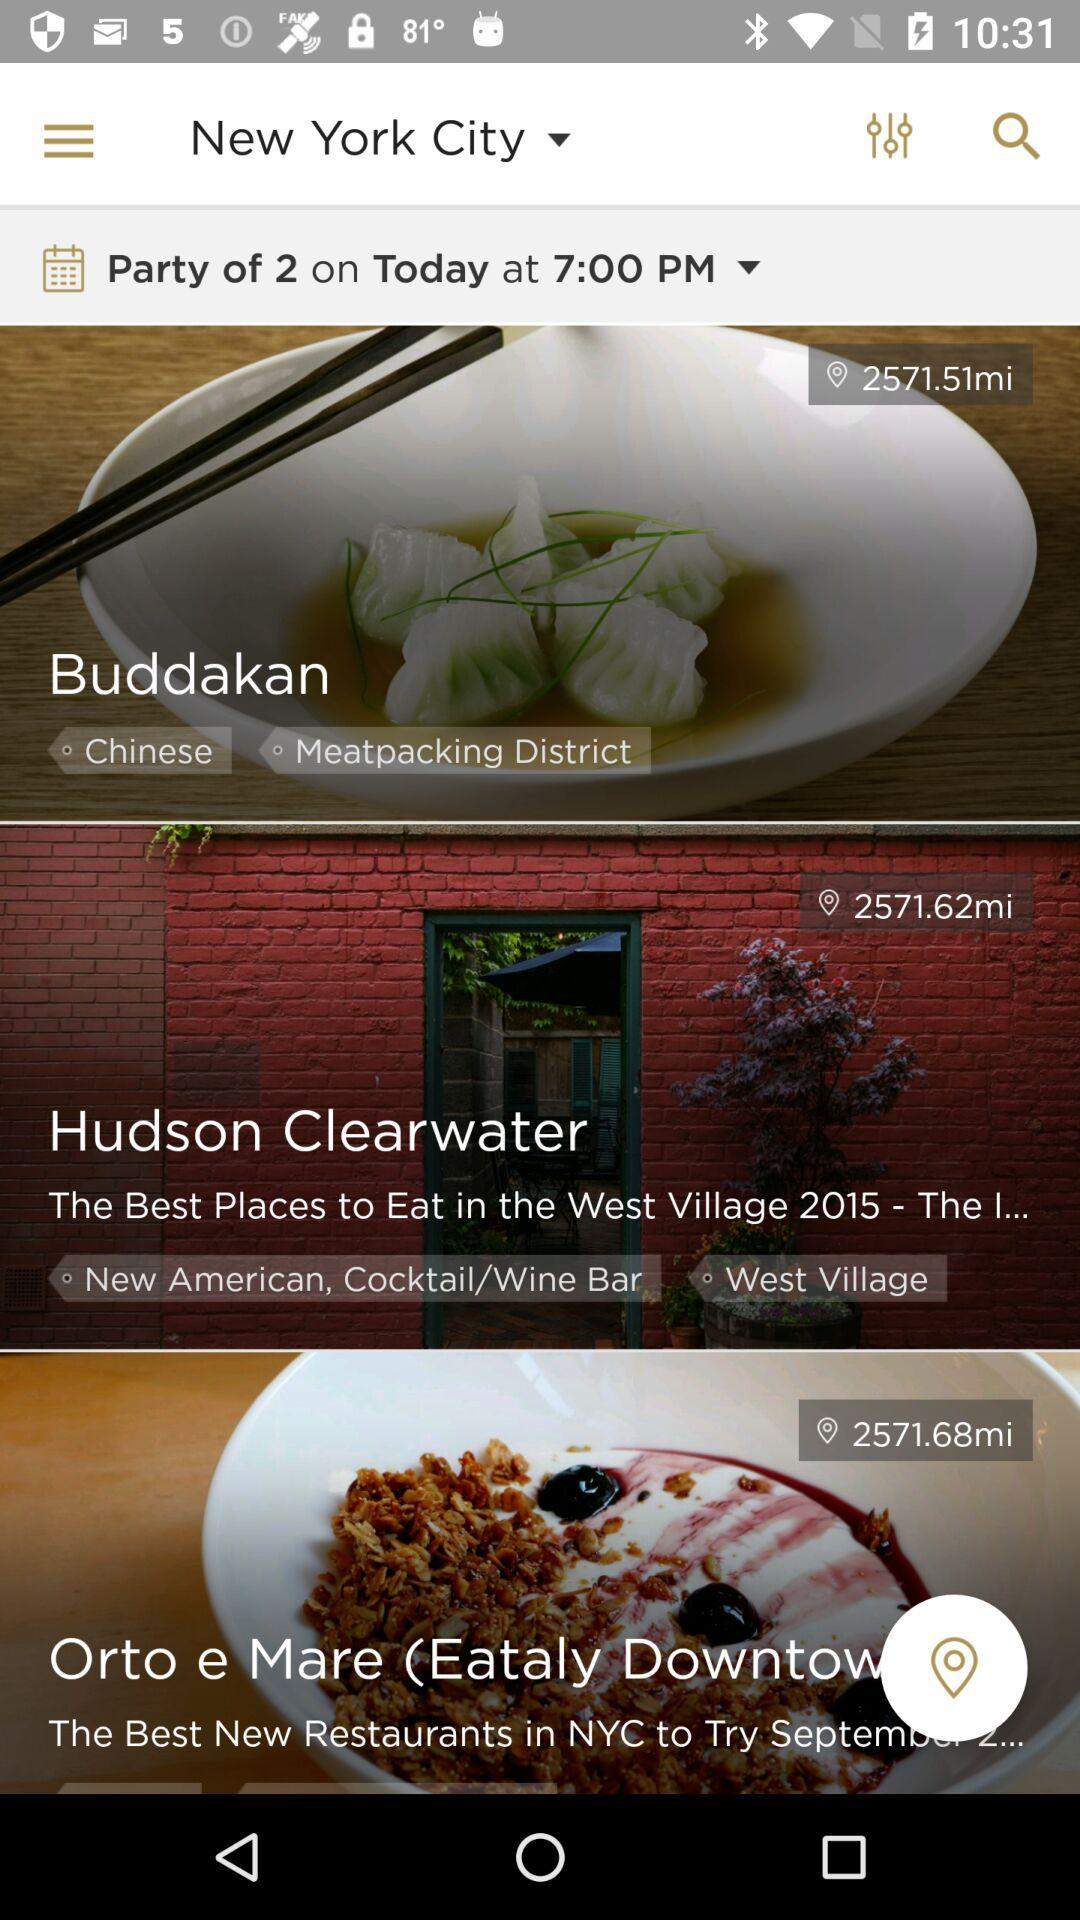Which restaurant serves Chinese cuisine? The restaurant that serves Chinese cuisine is "Buddakan". 